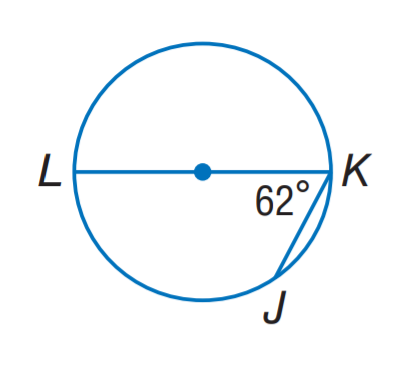Answer the mathemtical geometry problem and directly provide the correct option letter.
Question: Find m \widehat J K.
Choices: A: 34 B: 48 C: 56 D: 62 C 